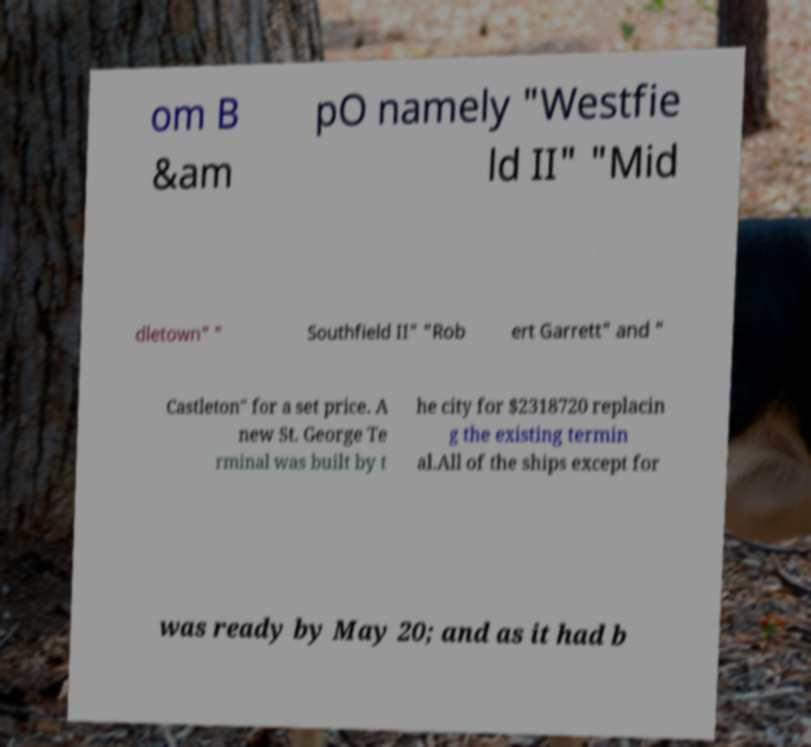For documentation purposes, I need the text within this image transcribed. Could you provide that? om B &am pO namely "Westfie ld II" "Mid dletown" " Southfield II" "Rob ert Garrett" and " Castleton" for a set price. A new St. George Te rminal was built by t he city for $2318720 replacin g the existing termin al.All of the ships except for was ready by May 20; and as it had b 